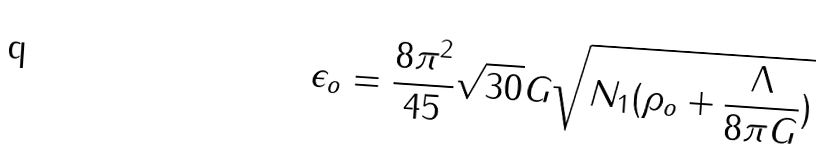Convert formula to latex. <formula><loc_0><loc_0><loc_500><loc_500>\epsilon _ { o } = \frac { 8 \pi ^ { 2 } } { 4 5 } \sqrt { 3 0 } G \sqrt { N _ { 1 } ( \rho _ { o } + \frac { \Lambda } { 8 \pi G } ) }</formula> 